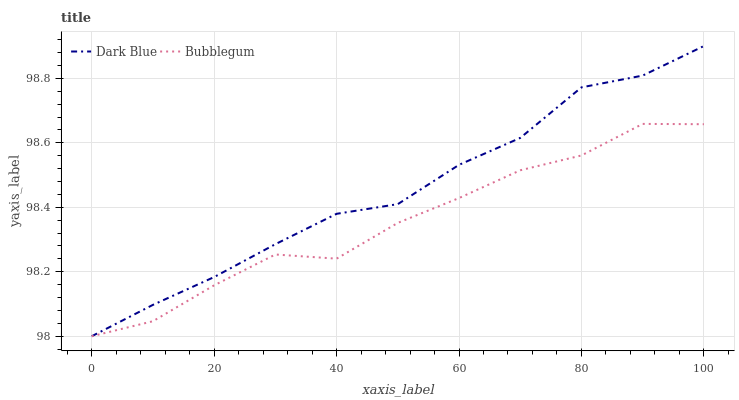Does Bubblegum have the minimum area under the curve?
Answer yes or no. Yes. Does Dark Blue have the maximum area under the curve?
Answer yes or no. Yes. Does Bubblegum have the maximum area under the curve?
Answer yes or no. No. Is Dark Blue the smoothest?
Answer yes or no. Yes. Is Bubblegum the roughest?
Answer yes or no. Yes. Is Bubblegum the smoothest?
Answer yes or no. No. Does Dark Blue have the lowest value?
Answer yes or no. Yes. Does Dark Blue have the highest value?
Answer yes or no. Yes. Does Bubblegum have the highest value?
Answer yes or no. No. Does Dark Blue intersect Bubblegum?
Answer yes or no. Yes. Is Dark Blue less than Bubblegum?
Answer yes or no. No. Is Dark Blue greater than Bubblegum?
Answer yes or no. No. 